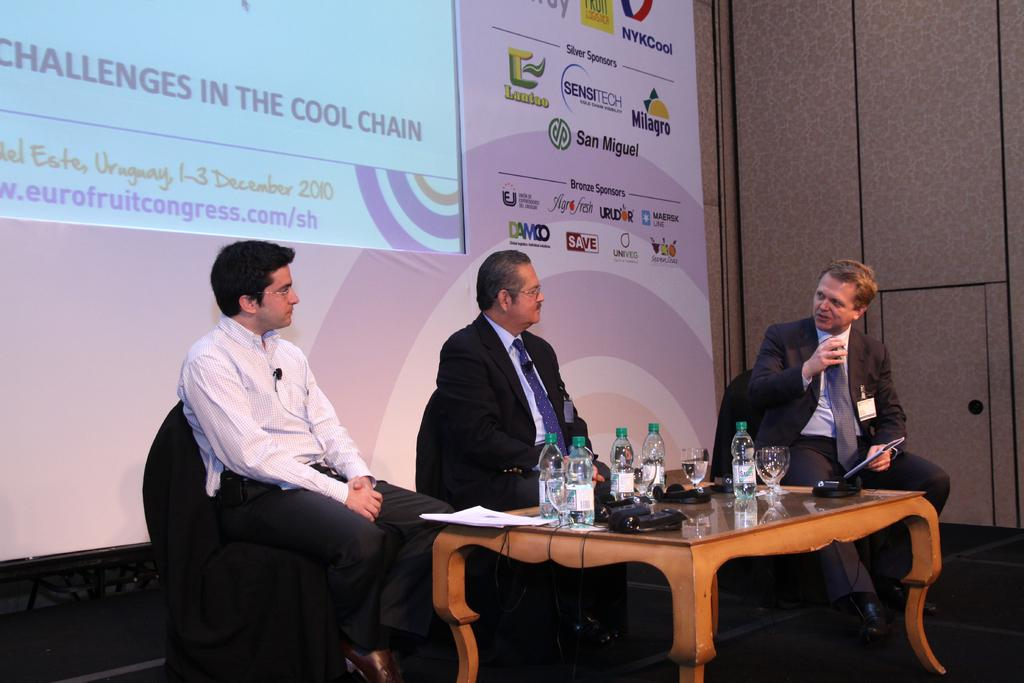What is the main subject of the image? The main subject of the image is a group of people. What are the people doing in the image? The people are seated on chairs. What items can be seen on the table in the image? There are water bottles and glasses on the table. What is the purpose of the screen visible in the image? The purpose of the screen is not specified, but it could be for a presentation or displaying information. Can you see any icicles hanging from the screen in the image? There are no icicles present in the image, as it is indoors and the screen is not exposed to cold temperatures. 